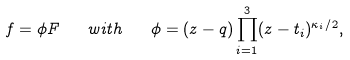<formula> <loc_0><loc_0><loc_500><loc_500>f = \phi F \quad w i t h \quad \phi = ( z - q ) \prod _ { i = 1 } ^ { 3 } ( z - t _ { i } ) ^ { \kappa _ { i } / 2 } ,</formula> 